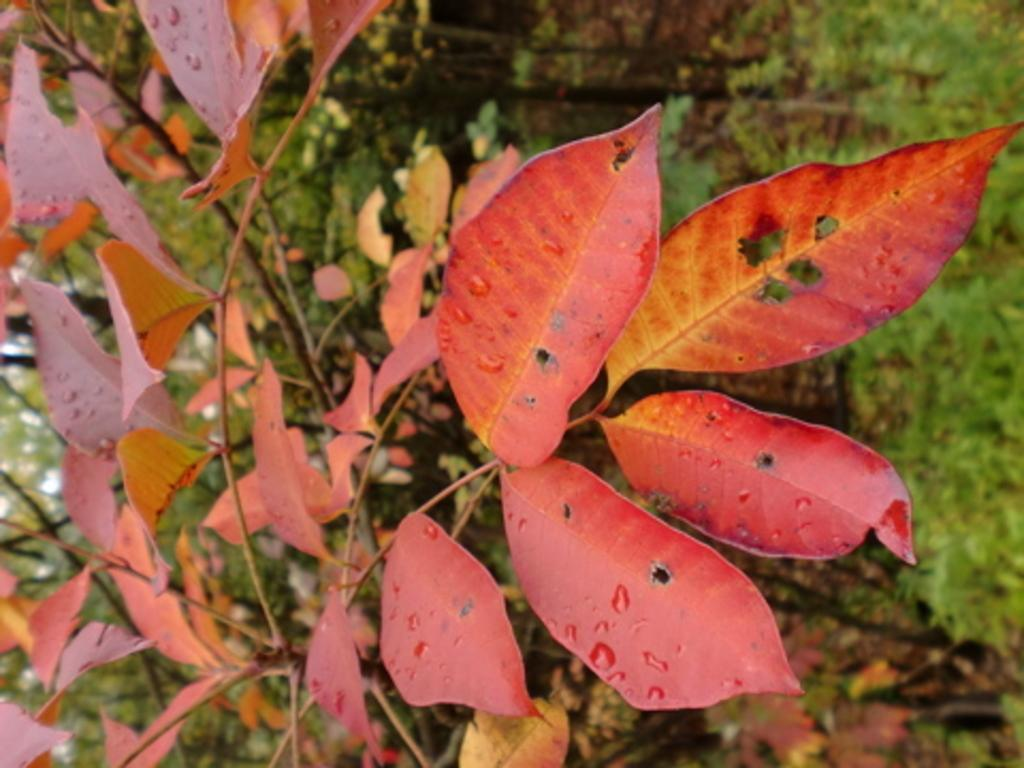What color are the leaves in the image? The leaves in the image are orange. What is on the leaves in the image? There is dew on the leaves in the image. How would you describe the background of the image? The background of the image is blurred. What type of vegetation can be seen in the background? There is grass visible in the background of the image. What book is the person reading in the image? There is no person or book present in the image; it features orange leaves with dew on them and a blurred background. 